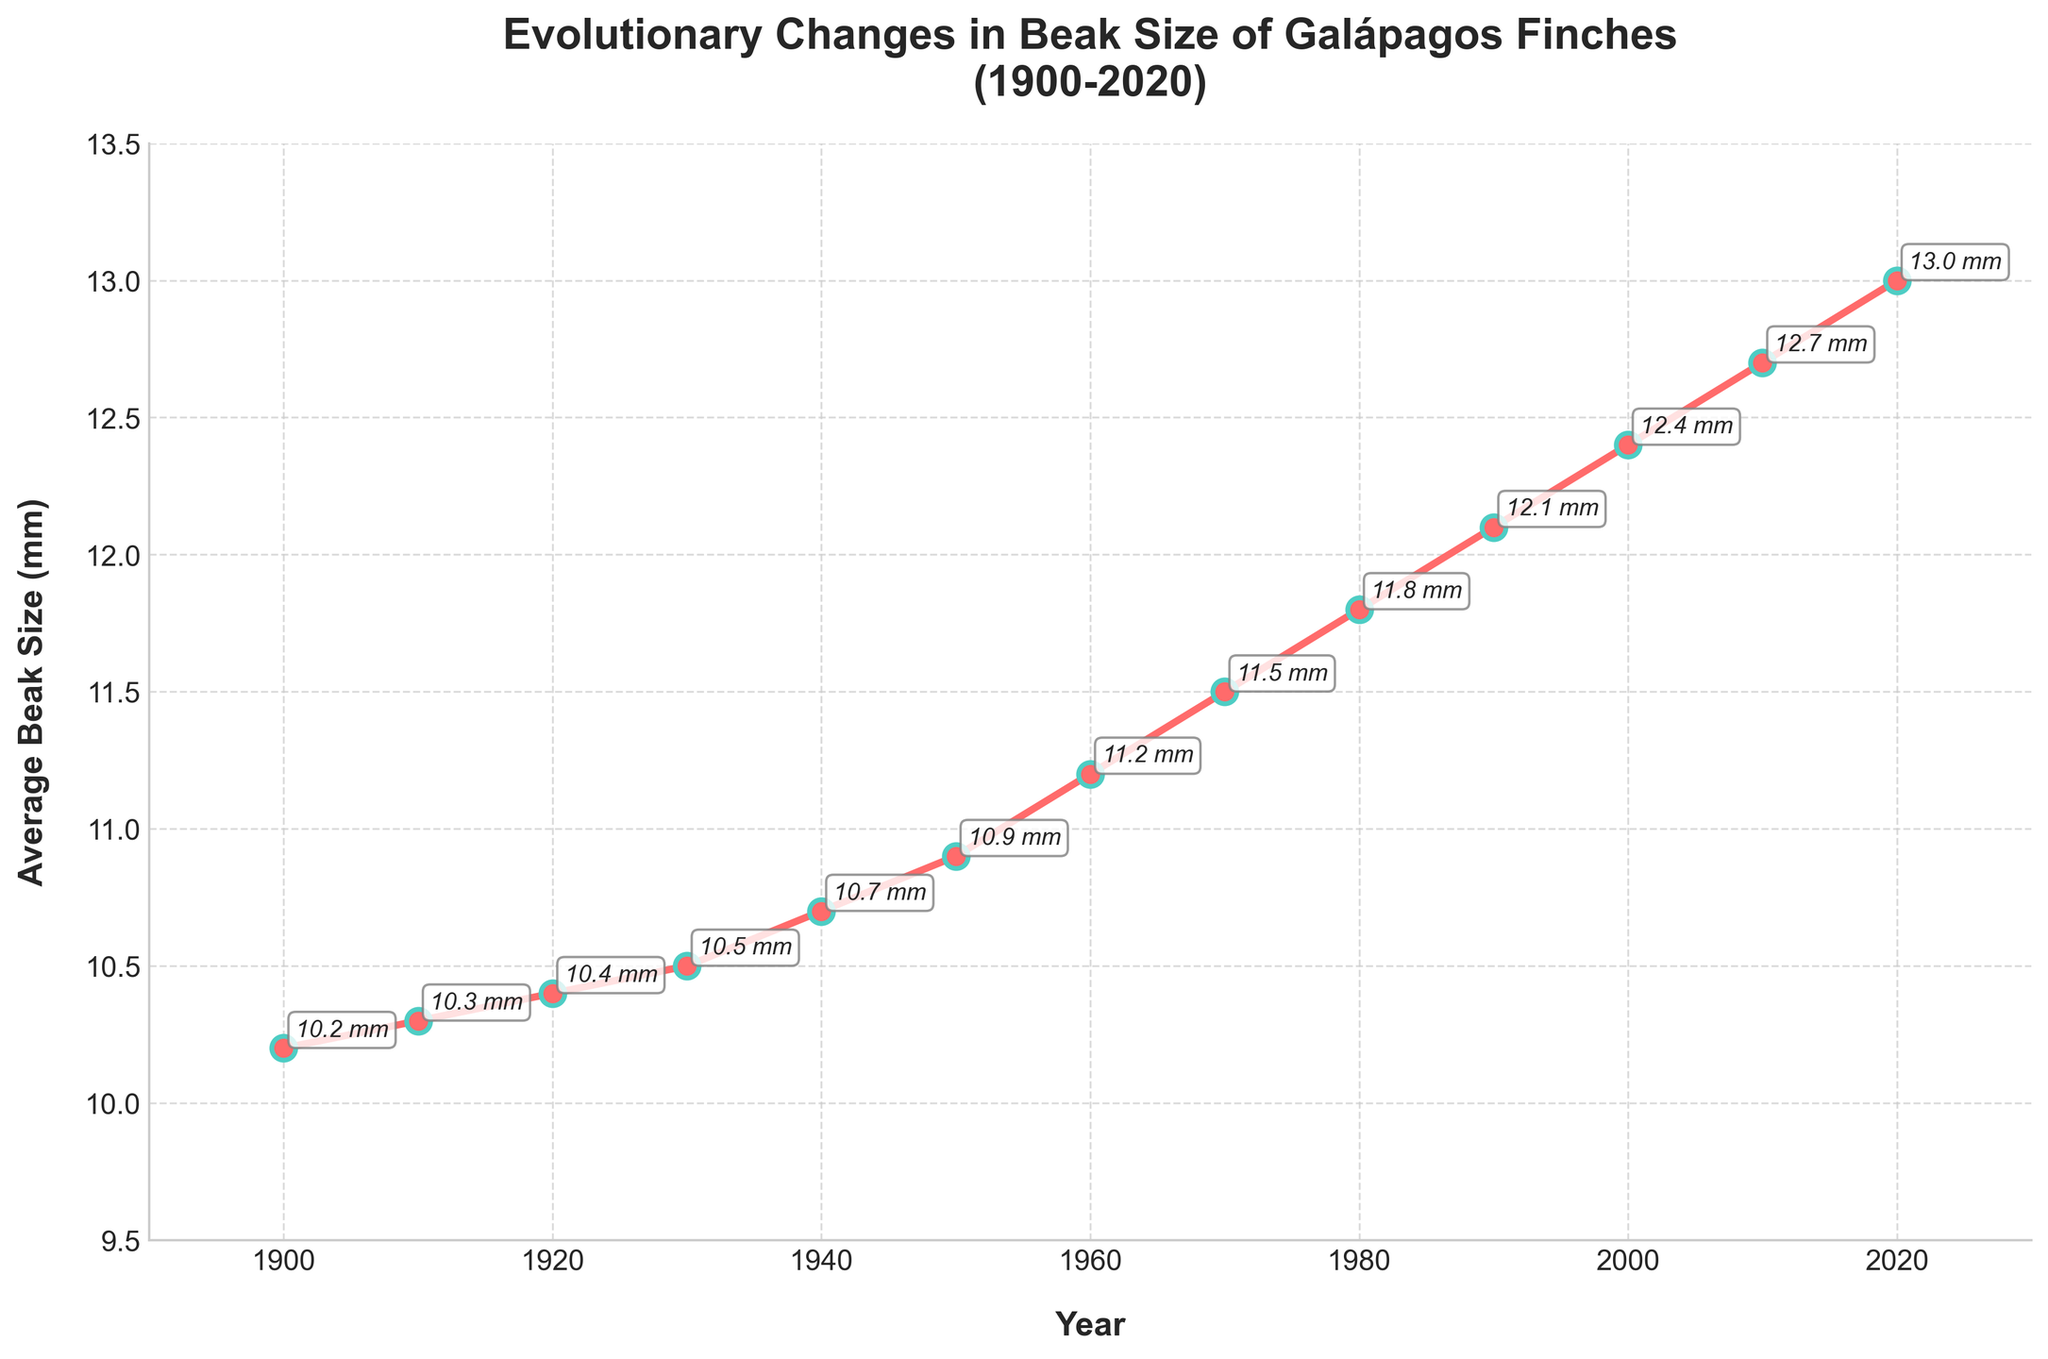What is the overall trend of beak size over the century? By analyzing the line chart from 1900 to 2020, we can observe that the average beak size of Galápagos finches consistently increases over this period, indicating a positive growth trend.
Answer: The trend is an increase in beak size What is the average beak size increase per decade? To find the average increase per decade, subtract the beak size in 1900 (10.2 mm) from the beak size in 2020 (13.0 mm), then divide by the number of decades (12). (13.0 mm - 10.2 mm) / 12 ≈ 0.233 mm per decade.
Answer: About 0.233 mm per decade Between which decade did the highest rate of increase in beak size occur? By comparing the differences in beak sizes between each consecutive decade, the highest increase occurs between 1940 (10.7 mm) and 1950 (10.9 mm), which is an increase of 0.2 mm.
Answer: Between 1940 and 1950 In which decades did the beak size increase the least? By comparing the differences in beak sizes from each decade to the next, the smallest increase is between 1900 (10.2 mm) and 1910 (10.3 mm), which is 0.1 mm.
Answer: 1900 to 1910 What is the total increase in average beak size from 1900 to 2020? Subtract the average beak size in 1900 from the average beak size in 2020. (13.0 mm - 10.2 mm) = 2.8 mm.
Answer: 2.8 mm Which decade showed a beak size of 12.1 mm? Refer to the annotated points on the chart, which indicate average beak sizes. The year 1990 is marked with 12.1 mm.
Answer: 1990 How many times did the beak size increase by more than 0.3 mm in a decade? Calculate the differences between each decade and count where the difference is more than 0.3 mm: from 1950-1960 (0.3 mm), 1960-1970 (0.3 mm), 1970-1980 (0.3 mm), 1980-1990 (0.3 mm), 1990-2000 (0.3 mm), 2000-2010 (0.3 mm), and 2010-2020 (0.3 mm), which is 7 occurrences.
Answer: 7 times What was the average beak size in the middle of the century (1950)? Find the annotated data point at 1950, which shows an average beak size of 10.9 mm.
Answer: 10.9 mm Which year marks the first time the average beak size exceeded 11 mm? Looking at the annotated points, 1960 (11.2 mm) is the first year when the average beak size exceeded 11 mm.
Answer: 1960 By how much did the average beak size increase from 1970 to 2020? Subtract the average beak size in 1970 (11.5 mm) from the beak size in 2020 (13.0 mm). (13.0 mm - 11.5 mm) = 1.5 mm.
Answer: 1.5 mm 